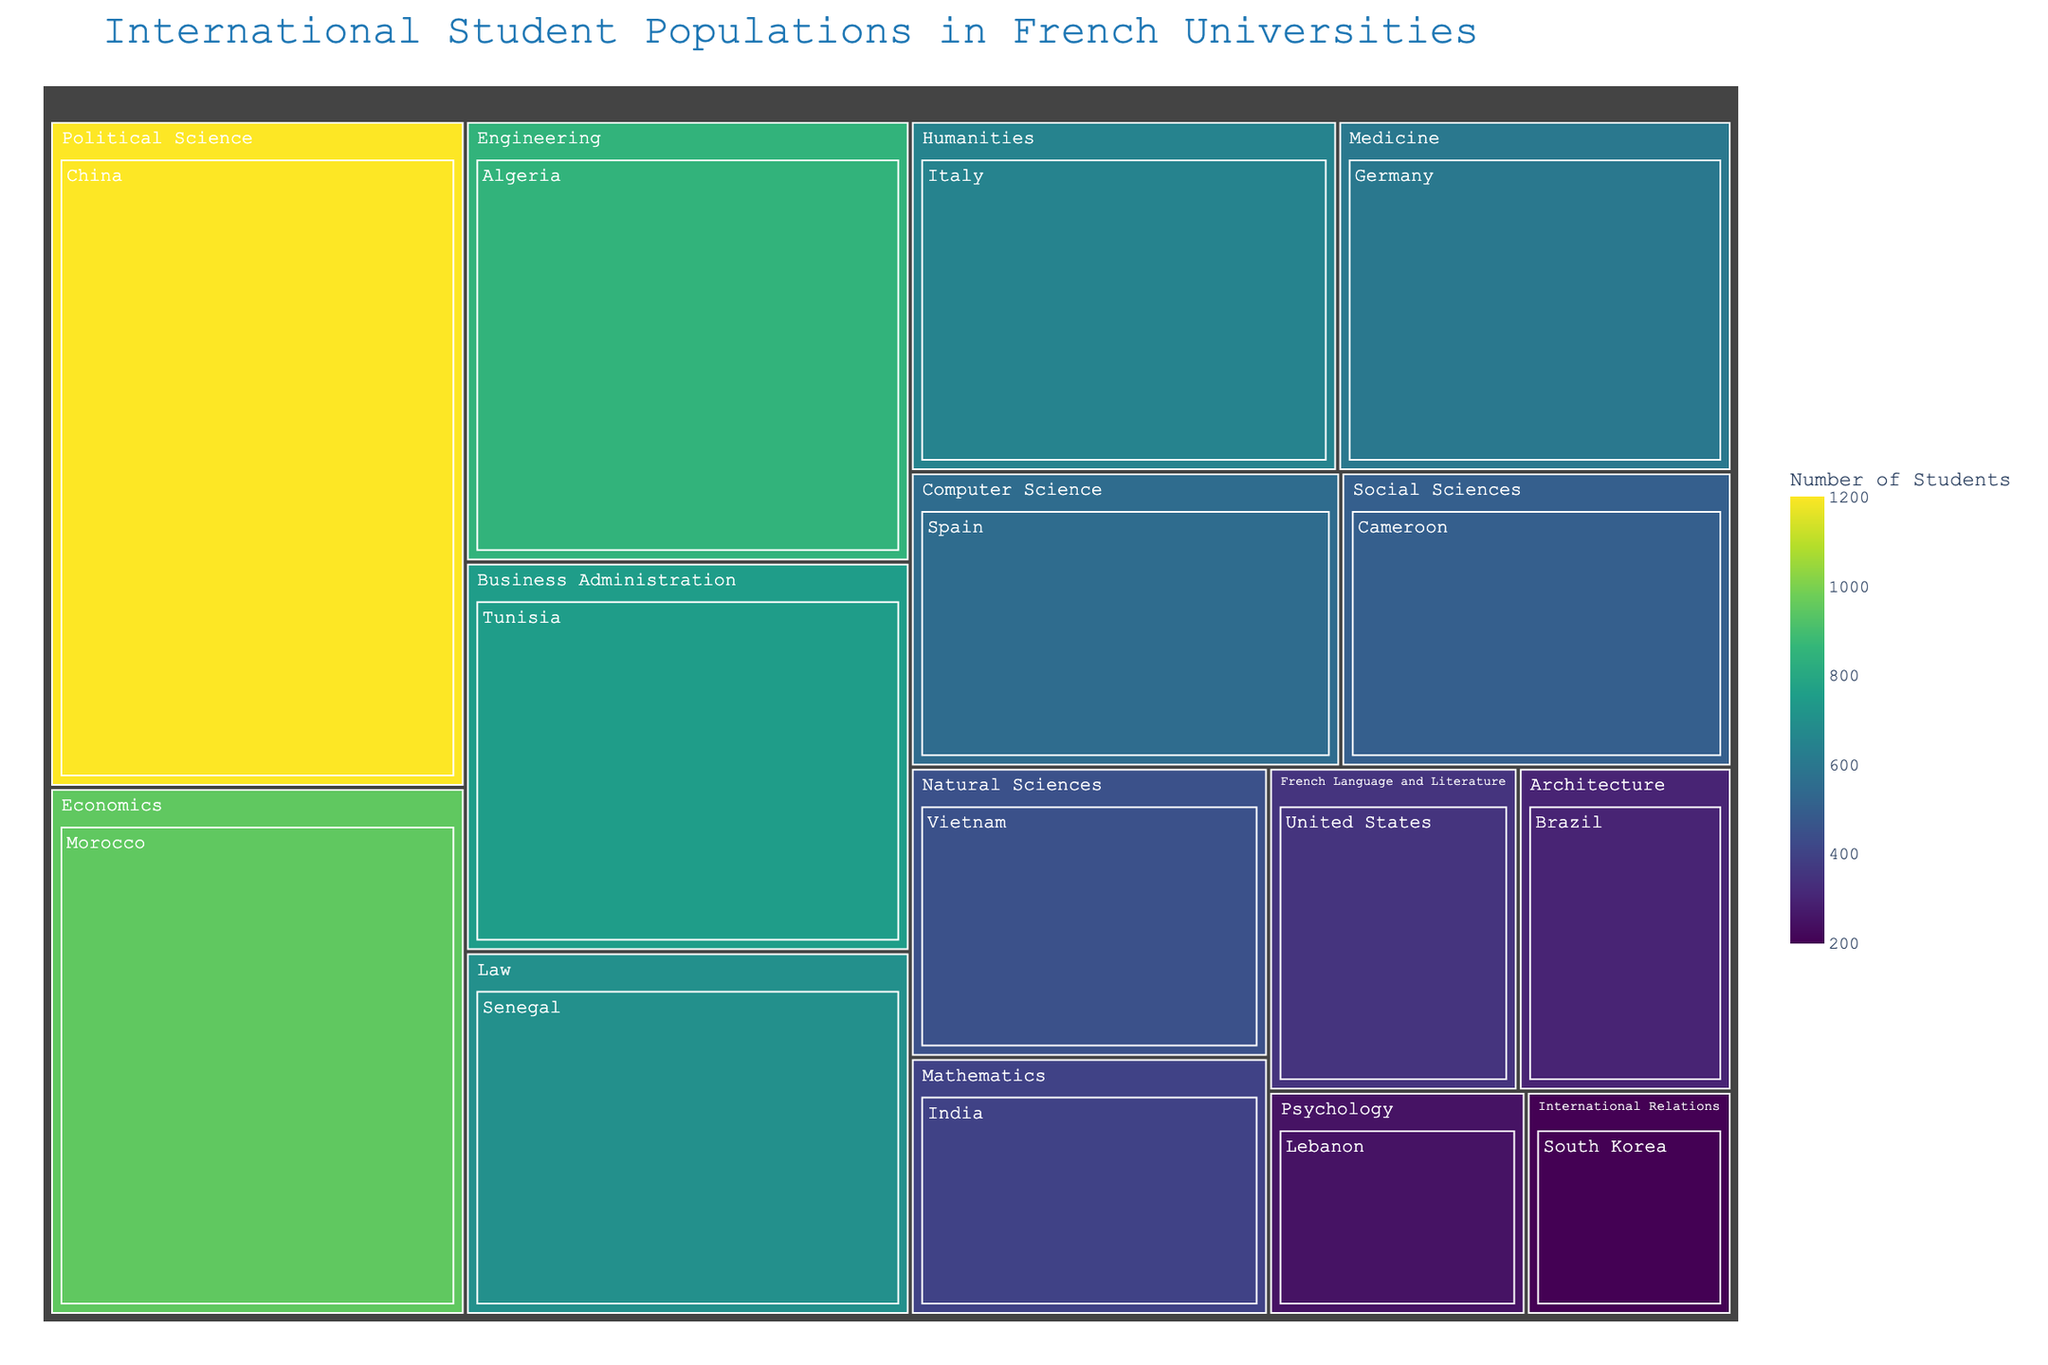What is the title of the figure? The title is usually displayed at the top of the figure in larger and bold font to indicate the subject of the visual representation.
Answer: International Student Populations in French Universities Which country has the most students studying Political Science? We can identify the largest segment in the Political Science part of the Treemap to find out the country.
Answer: China How many students from Morocco are studying Economics? By looking into the Economics section in the Treemap, we can find Morocco's entry and see the number of students.
Answer: 950 Identify the field of study with the highest number of students from Vietnam. In the Treemap, look for Vietnam under different fields to find which field has the largest section for Vietnam.
Answer: Natural Sciences What is the total number of students studying Engineering and Natural Sciences combined? To get the total, sum the number of students in Engineering and Natural Sciences categories. Engineering has 850 students and Natural Sciences has 450 students. 850 + 450 = 1300.
Answer: 1300 Which country has fewer than 500 students in French universities? By examining each segment for the number of students from different countries, identify those with fewer than 500 students.
Answer: Vietnam, Lebanon, South Korea, Brazil, United States, India Compare the number of students from Senegal and Cameroon. Which country has more students? Compare the sizes of the segments for Senegal and Cameroon to determine which country has a larger number of students.
Answer: Senegal In the Treemap, which field of study has the broadest diversity of countries represented? Count the number of countries listed under each field of study; the field with the most country entries has the broadest diversity.
Answer: Constitutional Law What is the overall range of student numbers among the countries in the Treemap? Identify the smallest and largest number of students among all countries, then calculate the difference. The smallest is South Korea (200) and the largest is China (1200). 1200 - 200 = 1000.
Answer: 1000 